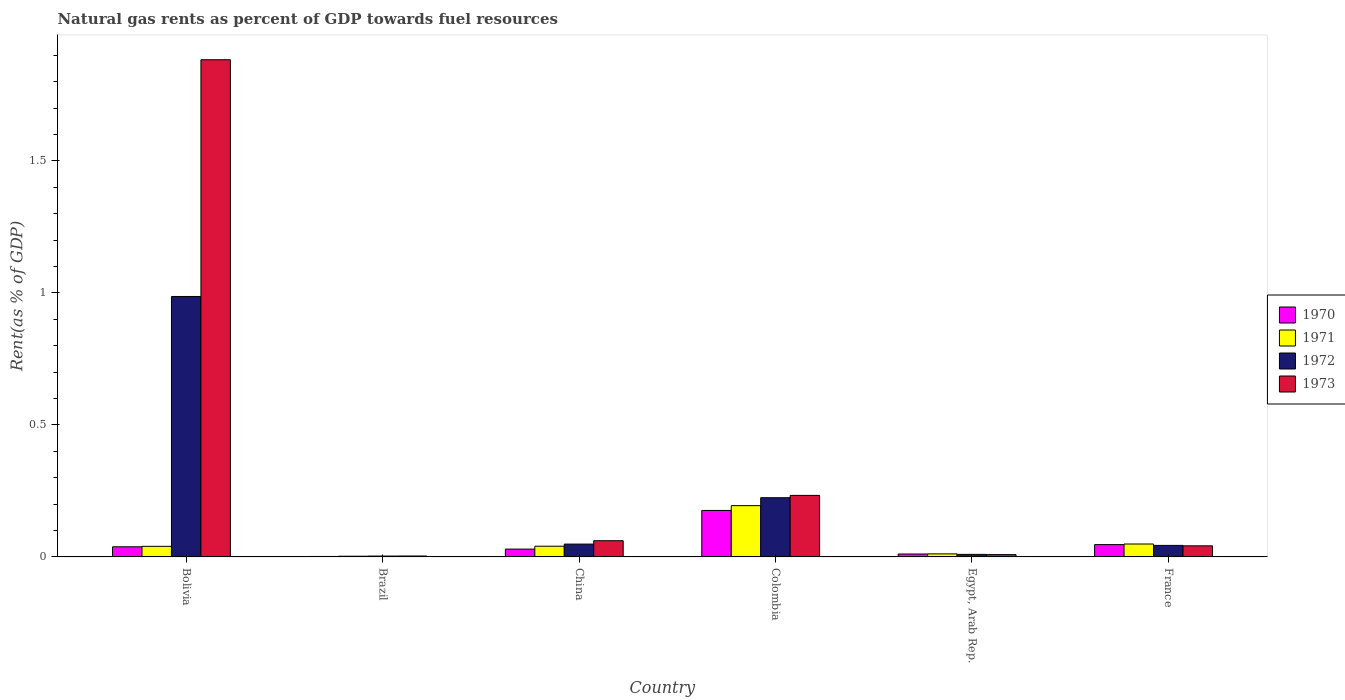How many different coloured bars are there?
Your answer should be compact. 4. Are the number of bars per tick equal to the number of legend labels?
Offer a very short reply. Yes. How many bars are there on the 6th tick from the right?
Make the answer very short. 4. What is the label of the 5th group of bars from the left?
Ensure brevity in your answer.  Egypt, Arab Rep. What is the matural gas rent in 1970 in Brazil?
Your response must be concise. 0. Across all countries, what is the maximum matural gas rent in 1971?
Provide a succinct answer. 0.19. Across all countries, what is the minimum matural gas rent in 1972?
Your answer should be very brief. 0. What is the total matural gas rent in 1971 in the graph?
Keep it short and to the point. 0.34. What is the difference between the matural gas rent in 1972 in Brazil and that in France?
Your response must be concise. -0.04. What is the difference between the matural gas rent in 1972 in China and the matural gas rent in 1971 in Egypt, Arab Rep.?
Offer a terse response. 0.04. What is the average matural gas rent in 1970 per country?
Give a very brief answer. 0.05. What is the difference between the matural gas rent of/in 1971 and matural gas rent of/in 1972 in Brazil?
Your response must be concise. -0. What is the ratio of the matural gas rent in 1971 in Colombia to that in France?
Keep it short and to the point. 3.97. What is the difference between the highest and the second highest matural gas rent in 1972?
Offer a terse response. 0.76. What is the difference between the highest and the lowest matural gas rent in 1970?
Provide a short and direct response. 0.17. Is the sum of the matural gas rent in 1971 in China and Colombia greater than the maximum matural gas rent in 1973 across all countries?
Your response must be concise. No. Is it the case that in every country, the sum of the matural gas rent in 1970 and matural gas rent in 1971 is greater than the sum of matural gas rent in 1973 and matural gas rent in 1972?
Provide a short and direct response. No. What does the 2nd bar from the left in China represents?
Make the answer very short. 1971. What does the 4th bar from the right in China represents?
Provide a succinct answer. 1970. Is it the case that in every country, the sum of the matural gas rent in 1972 and matural gas rent in 1973 is greater than the matural gas rent in 1971?
Provide a short and direct response. Yes. Does the graph contain grids?
Offer a very short reply. No. Where does the legend appear in the graph?
Offer a terse response. Center right. What is the title of the graph?
Make the answer very short. Natural gas rents as percent of GDP towards fuel resources. Does "1978" appear as one of the legend labels in the graph?
Offer a terse response. No. What is the label or title of the Y-axis?
Offer a terse response. Rent(as % of GDP). What is the Rent(as % of GDP) of 1970 in Bolivia?
Offer a very short reply. 0.04. What is the Rent(as % of GDP) of 1971 in Bolivia?
Keep it short and to the point. 0.04. What is the Rent(as % of GDP) in 1972 in Bolivia?
Provide a succinct answer. 0.99. What is the Rent(as % of GDP) in 1973 in Bolivia?
Keep it short and to the point. 1.88. What is the Rent(as % of GDP) in 1970 in Brazil?
Give a very brief answer. 0. What is the Rent(as % of GDP) in 1971 in Brazil?
Your answer should be compact. 0. What is the Rent(as % of GDP) in 1972 in Brazil?
Give a very brief answer. 0. What is the Rent(as % of GDP) in 1973 in Brazil?
Keep it short and to the point. 0. What is the Rent(as % of GDP) in 1970 in China?
Make the answer very short. 0.03. What is the Rent(as % of GDP) of 1971 in China?
Your answer should be compact. 0.04. What is the Rent(as % of GDP) of 1972 in China?
Provide a short and direct response. 0.05. What is the Rent(as % of GDP) in 1973 in China?
Ensure brevity in your answer.  0.06. What is the Rent(as % of GDP) in 1970 in Colombia?
Offer a terse response. 0.18. What is the Rent(as % of GDP) of 1971 in Colombia?
Your answer should be very brief. 0.19. What is the Rent(as % of GDP) of 1972 in Colombia?
Ensure brevity in your answer.  0.22. What is the Rent(as % of GDP) of 1973 in Colombia?
Provide a succinct answer. 0.23. What is the Rent(as % of GDP) of 1970 in Egypt, Arab Rep.?
Provide a succinct answer. 0.01. What is the Rent(as % of GDP) in 1971 in Egypt, Arab Rep.?
Offer a very short reply. 0.01. What is the Rent(as % of GDP) in 1972 in Egypt, Arab Rep.?
Provide a succinct answer. 0.01. What is the Rent(as % of GDP) of 1973 in Egypt, Arab Rep.?
Provide a succinct answer. 0.01. What is the Rent(as % of GDP) of 1970 in France?
Offer a very short reply. 0.05. What is the Rent(as % of GDP) of 1971 in France?
Offer a terse response. 0.05. What is the Rent(as % of GDP) in 1972 in France?
Provide a succinct answer. 0.04. What is the Rent(as % of GDP) of 1973 in France?
Give a very brief answer. 0.04. Across all countries, what is the maximum Rent(as % of GDP) of 1970?
Provide a short and direct response. 0.18. Across all countries, what is the maximum Rent(as % of GDP) in 1971?
Provide a short and direct response. 0.19. Across all countries, what is the maximum Rent(as % of GDP) of 1972?
Your response must be concise. 0.99. Across all countries, what is the maximum Rent(as % of GDP) in 1973?
Provide a succinct answer. 1.88. Across all countries, what is the minimum Rent(as % of GDP) of 1970?
Provide a short and direct response. 0. Across all countries, what is the minimum Rent(as % of GDP) of 1971?
Make the answer very short. 0. Across all countries, what is the minimum Rent(as % of GDP) in 1972?
Offer a very short reply. 0. Across all countries, what is the minimum Rent(as % of GDP) in 1973?
Offer a very short reply. 0. What is the total Rent(as % of GDP) in 1970 in the graph?
Provide a succinct answer. 0.3. What is the total Rent(as % of GDP) in 1971 in the graph?
Your answer should be compact. 0.34. What is the total Rent(as % of GDP) in 1972 in the graph?
Provide a succinct answer. 1.32. What is the total Rent(as % of GDP) in 1973 in the graph?
Your answer should be very brief. 2.23. What is the difference between the Rent(as % of GDP) in 1970 in Bolivia and that in Brazil?
Provide a short and direct response. 0.04. What is the difference between the Rent(as % of GDP) in 1971 in Bolivia and that in Brazil?
Make the answer very short. 0.04. What is the difference between the Rent(as % of GDP) of 1972 in Bolivia and that in Brazil?
Offer a very short reply. 0.98. What is the difference between the Rent(as % of GDP) of 1973 in Bolivia and that in Brazil?
Your answer should be compact. 1.88. What is the difference between the Rent(as % of GDP) of 1970 in Bolivia and that in China?
Give a very brief answer. 0.01. What is the difference between the Rent(as % of GDP) of 1971 in Bolivia and that in China?
Ensure brevity in your answer.  -0. What is the difference between the Rent(as % of GDP) in 1972 in Bolivia and that in China?
Offer a terse response. 0.94. What is the difference between the Rent(as % of GDP) of 1973 in Bolivia and that in China?
Your answer should be very brief. 1.82. What is the difference between the Rent(as % of GDP) in 1970 in Bolivia and that in Colombia?
Offer a terse response. -0.14. What is the difference between the Rent(as % of GDP) in 1971 in Bolivia and that in Colombia?
Your response must be concise. -0.15. What is the difference between the Rent(as % of GDP) of 1972 in Bolivia and that in Colombia?
Ensure brevity in your answer.  0.76. What is the difference between the Rent(as % of GDP) of 1973 in Bolivia and that in Colombia?
Make the answer very short. 1.65. What is the difference between the Rent(as % of GDP) in 1970 in Bolivia and that in Egypt, Arab Rep.?
Make the answer very short. 0.03. What is the difference between the Rent(as % of GDP) in 1971 in Bolivia and that in Egypt, Arab Rep.?
Make the answer very short. 0.03. What is the difference between the Rent(as % of GDP) in 1972 in Bolivia and that in Egypt, Arab Rep.?
Ensure brevity in your answer.  0.98. What is the difference between the Rent(as % of GDP) of 1973 in Bolivia and that in Egypt, Arab Rep.?
Provide a short and direct response. 1.87. What is the difference between the Rent(as % of GDP) in 1970 in Bolivia and that in France?
Ensure brevity in your answer.  -0.01. What is the difference between the Rent(as % of GDP) in 1971 in Bolivia and that in France?
Give a very brief answer. -0.01. What is the difference between the Rent(as % of GDP) of 1972 in Bolivia and that in France?
Provide a succinct answer. 0.94. What is the difference between the Rent(as % of GDP) in 1973 in Bolivia and that in France?
Your answer should be compact. 1.84. What is the difference between the Rent(as % of GDP) of 1970 in Brazil and that in China?
Your answer should be very brief. -0.03. What is the difference between the Rent(as % of GDP) of 1971 in Brazil and that in China?
Provide a succinct answer. -0.04. What is the difference between the Rent(as % of GDP) in 1972 in Brazil and that in China?
Offer a terse response. -0.05. What is the difference between the Rent(as % of GDP) in 1973 in Brazil and that in China?
Keep it short and to the point. -0.06. What is the difference between the Rent(as % of GDP) of 1970 in Brazil and that in Colombia?
Your response must be concise. -0.17. What is the difference between the Rent(as % of GDP) in 1971 in Brazil and that in Colombia?
Offer a very short reply. -0.19. What is the difference between the Rent(as % of GDP) in 1972 in Brazil and that in Colombia?
Provide a short and direct response. -0.22. What is the difference between the Rent(as % of GDP) in 1973 in Brazil and that in Colombia?
Your answer should be compact. -0.23. What is the difference between the Rent(as % of GDP) in 1970 in Brazil and that in Egypt, Arab Rep.?
Your answer should be very brief. -0.01. What is the difference between the Rent(as % of GDP) in 1971 in Brazil and that in Egypt, Arab Rep.?
Offer a terse response. -0.01. What is the difference between the Rent(as % of GDP) in 1972 in Brazil and that in Egypt, Arab Rep.?
Your response must be concise. -0.01. What is the difference between the Rent(as % of GDP) of 1973 in Brazil and that in Egypt, Arab Rep.?
Your answer should be very brief. -0.01. What is the difference between the Rent(as % of GDP) of 1970 in Brazil and that in France?
Give a very brief answer. -0.04. What is the difference between the Rent(as % of GDP) in 1971 in Brazil and that in France?
Your answer should be compact. -0.05. What is the difference between the Rent(as % of GDP) of 1972 in Brazil and that in France?
Offer a very short reply. -0.04. What is the difference between the Rent(as % of GDP) of 1973 in Brazil and that in France?
Offer a very short reply. -0.04. What is the difference between the Rent(as % of GDP) in 1970 in China and that in Colombia?
Make the answer very short. -0.15. What is the difference between the Rent(as % of GDP) of 1971 in China and that in Colombia?
Make the answer very short. -0.15. What is the difference between the Rent(as % of GDP) of 1972 in China and that in Colombia?
Provide a succinct answer. -0.18. What is the difference between the Rent(as % of GDP) of 1973 in China and that in Colombia?
Your answer should be compact. -0.17. What is the difference between the Rent(as % of GDP) in 1970 in China and that in Egypt, Arab Rep.?
Offer a terse response. 0.02. What is the difference between the Rent(as % of GDP) of 1971 in China and that in Egypt, Arab Rep.?
Give a very brief answer. 0.03. What is the difference between the Rent(as % of GDP) of 1972 in China and that in Egypt, Arab Rep.?
Provide a succinct answer. 0.04. What is the difference between the Rent(as % of GDP) in 1973 in China and that in Egypt, Arab Rep.?
Give a very brief answer. 0.05. What is the difference between the Rent(as % of GDP) of 1970 in China and that in France?
Give a very brief answer. -0.02. What is the difference between the Rent(as % of GDP) in 1971 in China and that in France?
Give a very brief answer. -0.01. What is the difference between the Rent(as % of GDP) of 1972 in China and that in France?
Your response must be concise. 0.01. What is the difference between the Rent(as % of GDP) in 1973 in China and that in France?
Your answer should be compact. 0.02. What is the difference between the Rent(as % of GDP) in 1970 in Colombia and that in Egypt, Arab Rep.?
Ensure brevity in your answer.  0.16. What is the difference between the Rent(as % of GDP) of 1971 in Colombia and that in Egypt, Arab Rep.?
Ensure brevity in your answer.  0.18. What is the difference between the Rent(as % of GDP) of 1972 in Colombia and that in Egypt, Arab Rep.?
Make the answer very short. 0.21. What is the difference between the Rent(as % of GDP) of 1973 in Colombia and that in Egypt, Arab Rep.?
Your answer should be very brief. 0.22. What is the difference between the Rent(as % of GDP) of 1970 in Colombia and that in France?
Provide a succinct answer. 0.13. What is the difference between the Rent(as % of GDP) of 1971 in Colombia and that in France?
Give a very brief answer. 0.15. What is the difference between the Rent(as % of GDP) in 1972 in Colombia and that in France?
Make the answer very short. 0.18. What is the difference between the Rent(as % of GDP) of 1973 in Colombia and that in France?
Offer a terse response. 0.19. What is the difference between the Rent(as % of GDP) in 1970 in Egypt, Arab Rep. and that in France?
Provide a short and direct response. -0.04. What is the difference between the Rent(as % of GDP) of 1971 in Egypt, Arab Rep. and that in France?
Your answer should be very brief. -0.04. What is the difference between the Rent(as % of GDP) in 1972 in Egypt, Arab Rep. and that in France?
Give a very brief answer. -0.03. What is the difference between the Rent(as % of GDP) in 1973 in Egypt, Arab Rep. and that in France?
Offer a terse response. -0.03. What is the difference between the Rent(as % of GDP) in 1970 in Bolivia and the Rent(as % of GDP) in 1971 in Brazil?
Your answer should be very brief. 0.04. What is the difference between the Rent(as % of GDP) of 1970 in Bolivia and the Rent(as % of GDP) of 1972 in Brazil?
Your answer should be very brief. 0.04. What is the difference between the Rent(as % of GDP) in 1970 in Bolivia and the Rent(as % of GDP) in 1973 in Brazil?
Give a very brief answer. 0.03. What is the difference between the Rent(as % of GDP) of 1971 in Bolivia and the Rent(as % of GDP) of 1972 in Brazil?
Your answer should be compact. 0.04. What is the difference between the Rent(as % of GDP) of 1971 in Bolivia and the Rent(as % of GDP) of 1973 in Brazil?
Keep it short and to the point. 0.04. What is the difference between the Rent(as % of GDP) in 1972 in Bolivia and the Rent(as % of GDP) in 1973 in Brazil?
Give a very brief answer. 0.98. What is the difference between the Rent(as % of GDP) in 1970 in Bolivia and the Rent(as % of GDP) in 1971 in China?
Your answer should be very brief. -0. What is the difference between the Rent(as % of GDP) of 1970 in Bolivia and the Rent(as % of GDP) of 1972 in China?
Provide a short and direct response. -0.01. What is the difference between the Rent(as % of GDP) of 1970 in Bolivia and the Rent(as % of GDP) of 1973 in China?
Your answer should be compact. -0.02. What is the difference between the Rent(as % of GDP) of 1971 in Bolivia and the Rent(as % of GDP) of 1972 in China?
Your answer should be very brief. -0.01. What is the difference between the Rent(as % of GDP) of 1971 in Bolivia and the Rent(as % of GDP) of 1973 in China?
Make the answer very short. -0.02. What is the difference between the Rent(as % of GDP) of 1972 in Bolivia and the Rent(as % of GDP) of 1973 in China?
Give a very brief answer. 0.92. What is the difference between the Rent(as % of GDP) in 1970 in Bolivia and the Rent(as % of GDP) in 1971 in Colombia?
Ensure brevity in your answer.  -0.16. What is the difference between the Rent(as % of GDP) of 1970 in Bolivia and the Rent(as % of GDP) of 1972 in Colombia?
Offer a very short reply. -0.19. What is the difference between the Rent(as % of GDP) of 1970 in Bolivia and the Rent(as % of GDP) of 1973 in Colombia?
Offer a very short reply. -0.19. What is the difference between the Rent(as % of GDP) of 1971 in Bolivia and the Rent(as % of GDP) of 1972 in Colombia?
Your answer should be compact. -0.18. What is the difference between the Rent(as % of GDP) of 1971 in Bolivia and the Rent(as % of GDP) of 1973 in Colombia?
Keep it short and to the point. -0.19. What is the difference between the Rent(as % of GDP) in 1972 in Bolivia and the Rent(as % of GDP) in 1973 in Colombia?
Provide a succinct answer. 0.75. What is the difference between the Rent(as % of GDP) of 1970 in Bolivia and the Rent(as % of GDP) of 1971 in Egypt, Arab Rep.?
Your response must be concise. 0.03. What is the difference between the Rent(as % of GDP) of 1970 in Bolivia and the Rent(as % of GDP) of 1972 in Egypt, Arab Rep.?
Provide a short and direct response. 0.03. What is the difference between the Rent(as % of GDP) of 1970 in Bolivia and the Rent(as % of GDP) of 1973 in Egypt, Arab Rep.?
Provide a short and direct response. 0.03. What is the difference between the Rent(as % of GDP) of 1971 in Bolivia and the Rent(as % of GDP) of 1972 in Egypt, Arab Rep.?
Your answer should be compact. 0.03. What is the difference between the Rent(as % of GDP) of 1971 in Bolivia and the Rent(as % of GDP) of 1973 in Egypt, Arab Rep.?
Your answer should be very brief. 0.03. What is the difference between the Rent(as % of GDP) of 1972 in Bolivia and the Rent(as % of GDP) of 1973 in Egypt, Arab Rep.?
Your answer should be compact. 0.98. What is the difference between the Rent(as % of GDP) of 1970 in Bolivia and the Rent(as % of GDP) of 1971 in France?
Offer a terse response. -0.01. What is the difference between the Rent(as % of GDP) of 1970 in Bolivia and the Rent(as % of GDP) of 1972 in France?
Give a very brief answer. -0.01. What is the difference between the Rent(as % of GDP) in 1970 in Bolivia and the Rent(as % of GDP) in 1973 in France?
Provide a succinct answer. -0. What is the difference between the Rent(as % of GDP) of 1971 in Bolivia and the Rent(as % of GDP) of 1972 in France?
Your response must be concise. -0. What is the difference between the Rent(as % of GDP) of 1971 in Bolivia and the Rent(as % of GDP) of 1973 in France?
Provide a succinct answer. -0. What is the difference between the Rent(as % of GDP) in 1972 in Bolivia and the Rent(as % of GDP) in 1973 in France?
Keep it short and to the point. 0.94. What is the difference between the Rent(as % of GDP) of 1970 in Brazil and the Rent(as % of GDP) of 1971 in China?
Offer a terse response. -0.04. What is the difference between the Rent(as % of GDP) of 1970 in Brazil and the Rent(as % of GDP) of 1972 in China?
Offer a terse response. -0.05. What is the difference between the Rent(as % of GDP) of 1970 in Brazil and the Rent(as % of GDP) of 1973 in China?
Your answer should be very brief. -0.06. What is the difference between the Rent(as % of GDP) in 1971 in Brazil and the Rent(as % of GDP) in 1972 in China?
Provide a succinct answer. -0.05. What is the difference between the Rent(as % of GDP) of 1971 in Brazil and the Rent(as % of GDP) of 1973 in China?
Your answer should be compact. -0.06. What is the difference between the Rent(as % of GDP) of 1972 in Brazil and the Rent(as % of GDP) of 1973 in China?
Make the answer very short. -0.06. What is the difference between the Rent(as % of GDP) of 1970 in Brazil and the Rent(as % of GDP) of 1971 in Colombia?
Give a very brief answer. -0.19. What is the difference between the Rent(as % of GDP) in 1970 in Brazil and the Rent(as % of GDP) in 1972 in Colombia?
Give a very brief answer. -0.22. What is the difference between the Rent(as % of GDP) of 1970 in Brazil and the Rent(as % of GDP) of 1973 in Colombia?
Provide a short and direct response. -0.23. What is the difference between the Rent(as % of GDP) of 1971 in Brazil and the Rent(as % of GDP) of 1972 in Colombia?
Offer a terse response. -0.22. What is the difference between the Rent(as % of GDP) of 1971 in Brazil and the Rent(as % of GDP) of 1973 in Colombia?
Offer a terse response. -0.23. What is the difference between the Rent(as % of GDP) of 1972 in Brazil and the Rent(as % of GDP) of 1973 in Colombia?
Provide a short and direct response. -0.23. What is the difference between the Rent(as % of GDP) of 1970 in Brazil and the Rent(as % of GDP) of 1971 in Egypt, Arab Rep.?
Ensure brevity in your answer.  -0.01. What is the difference between the Rent(as % of GDP) in 1970 in Brazil and the Rent(as % of GDP) in 1972 in Egypt, Arab Rep.?
Make the answer very short. -0.01. What is the difference between the Rent(as % of GDP) of 1970 in Brazil and the Rent(as % of GDP) of 1973 in Egypt, Arab Rep.?
Keep it short and to the point. -0.01. What is the difference between the Rent(as % of GDP) in 1971 in Brazil and the Rent(as % of GDP) in 1972 in Egypt, Arab Rep.?
Provide a succinct answer. -0.01. What is the difference between the Rent(as % of GDP) of 1971 in Brazil and the Rent(as % of GDP) of 1973 in Egypt, Arab Rep.?
Provide a succinct answer. -0.01. What is the difference between the Rent(as % of GDP) of 1972 in Brazil and the Rent(as % of GDP) of 1973 in Egypt, Arab Rep.?
Give a very brief answer. -0.01. What is the difference between the Rent(as % of GDP) in 1970 in Brazil and the Rent(as % of GDP) in 1971 in France?
Ensure brevity in your answer.  -0.05. What is the difference between the Rent(as % of GDP) of 1970 in Brazil and the Rent(as % of GDP) of 1972 in France?
Keep it short and to the point. -0.04. What is the difference between the Rent(as % of GDP) in 1970 in Brazil and the Rent(as % of GDP) in 1973 in France?
Offer a very short reply. -0.04. What is the difference between the Rent(as % of GDP) in 1971 in Brazil and the Rent(as % of GDP) in 1972 in France?
Offer a terse response. -0.04. What is the difference between the Rent(as % of GDP) of 1971 in Brazil and the Rent(as % of GDP) of 1973 in France?
Provide a short and direct response. -0.04. What is the difference between the Rent(as % of GDP) of 1972 in Brazil and the Rent(as % of GDP) of 1973 in France?
Your answer should be compact. -0.04. What is the difference between the Rent(as % of GDP) in 1970 in China and the Rent(as % of GDP) in 1971 in Colombia?
Ensure brevity in your answer.  -0.16. What is the difference between the Rent(as % of GDP) of 1970 in China and the Rent(as % of GDP) of 1972 in Colombia?
Give a very brief answer. -0.19. What is the difference between the Rent(as % of GDP) in 1970 in China and the Rent(as % of GDP) in 1973 in Colombia?
Your response must be concise. -0.2. What is the difference between the Rent(as % of GDP) of 1971 in China and the Rent(as % of GDP) of 1972 in Colombia?
Make the answer very short. -0.18. What is the difference between the Rent(as % of GDP) in 1971 in China and the Rent(as % of GDP) in 1973 in Colombia?
Make the answer very short. -0.19. What is the difference between the Rent(as % of GDP) in 1972 in China and the Rent(as % of GDP) in 1973 in Colombia?
Provide a short and direct response. -0.18. What is the difference between the Rent(as % of GDP) in 1970 in China and the Rent(as % of GDP) in 1971 in Egypt, Arab Rep.?
Offer a terse response. 0.02. What is the difference between the Rent(as % of GDP) in 1970 in China and the Rent(as % of GDP) in 1972 in Egypt, Arab Rep.?
Provide a short and direct response. 0.02. What is the difference between the Rent(as % of GDP) in 1970 in China and the Rent(as % of GDP) in 1973 in Egypt, Arab Rep.?
Your answer should be very brief. 0.02. What is the difference between the Rent(as % of GDP) in 1971 in China and the Rent(as % of GDP) in 1972 in Egypt, Arab Rep.?
Give a very brief answer. 0.03. What is the difference between the Rent(as % of GDP) of 1971 in China and the Rent(as % of GDP) of 1973 in Egypt, Arab Rep.?
Make the answer very short. 0.03. What is the difference between the Rent(as % of GDP) of 1972 in China and the Rent(as % of GDP) of 1973 in Egypt, Arab Rep.?
Your answer should be very brief. 0.04. What is the difference between the Rent(as % of GDP) in 1970 in China and the Rent(as % of GDP) in 1971 in France?
Provide a short and direct response. -0.02. What is the difference between the Rent(as % of GDP) in 1970 in China and the Rent(as % of GDP) in 1972 in France?
Your answer should be very brief. -0.01. What is the difference between the Rent(as % of GDP) in 1970 in China and the Rent(as % of GDP) in 1973 in France?
Give a very brief answer. -0.01. What is the difference between the Rent(as % of GDP) of 1971 in China and the Rent(as % of GDP) of 1972 in France?
Ensure brevity in your answer.  -0. What is the difference between the Rent(as % of GDP) in 1971 in China and the Rent(as % of GDP) in 1973 in France?
Offer a terse response. -0. What is the difference between the Rent(as % of GDP) in 1972 in China and the Rent(as % of GDP) in 1973 in France?
Your answer should be compact. 0.01. What is the difference between the Rent(as % of GDP) in 1970 in Colombia and the Rent(as % of GDP) in 1971 in Egypt, Arab Rep.?
Ensure brevity in your answer.  0.16. What is the difference between the Rent(as % of GDP) in 1970 in Colombia and the Rent(as % of GDP) in 1972 in Egypt, Arab Rep.?
Give a very brief answer. 0.17. What is the difference between the Rent(as % of GDP) of 1970 in Colombia and the Rent(as % of GDP) of 1973 in Egypt, Arab Rep.?
Your answer should be very brief. 0.17. What is the difference between the Rent(as % of GDP) in 1971 in Colombia and the Rent(as % of GDP) in 1972 in Egypt, Arab Rep.?
Make the answer very short. 0.18. What is the difference between the Rent(as % of GDP) in 1971 in Colombia and the Rent(as % of GDP) in 1973 in Egypt, Arab Rep.?
Your answer should be compact. 0.19. What is the difference between the Rent(as % of GDP) in 1972 in Colombia and the Rent(as % of GDP) in 1973 in Egypt, Arab Rep.?
Your answer should be compact. 0.22. What is the difference between the Rent(as % of GDP) of 1970 in Colombia and the Rent(as % of GDP) of 1971 in France?
Keep it short and to the point. 0.13. What is the difference between the Rent(as % of GDP) in 1970 in Colombia and the Rent(as % of GDP) in 1972 in France?
Provide a short and direct response. 0.13. What is the difference between the Rent(as % of GDP) in 1970 in Colombia and the Rent(as % of GDP) in 1973 in France?
Make the answer very short. 0.13. What is the difference between the Rent(as % of GDP) of 1971 in Colombia and the Rent(as % of GDP) of 1972 in France?
Offer a very short reply. 0.15. What is the difference between the Rent(as % of GDP) of 1971 in Colombia and the Rent(as % of GDP) of 1973 in France?
Make the answer very short. 0.15. What is the difference between the Rent(as % of GDP) in 1972 in Colombia and the Rent(as % of GDP) in 1973 in France?
Offer a terse response. 0.18. What is the difference between the Rent(as % of GDP) in 1970 in Egypt, Arab Rep. and the Rent(as % of GDP) in 1971 in France?
Provide a short and direct response. -0.04. What is the difference between the Rent(as % of GDP) of 1970 in Egypt, Arab Rep. and the Rent(as % of GDP) of 1972 in France?
Ensure brevity in your answer.  -0.03. What is the difference between the Rent(as % of GDP) of 1970 in Egypt, Arab Rep. and the Rent(as % of GDP) of 1973 in France?
Ensure brevity in your answer.  -0.03. What is the difference between the Rent(as % of GDP) of 1971 in Egypt, Arab Rep. and the Rent(as % of GDP) of 1972 in France?
Provide a short and direct response. -0.03. What is the difference between the Rent(as % of GDP) in 1971 in Egypt, Arab Rep. and the Rent(as % of GDP) in 1973 in France?
Give a very brief answer. -0.03. What is the difference between the Rent(as % of GDP) of 1972 in Egypt, Arab Rep. and the Rent(as % of GDP) of 1973 in France?
Keep it short and to the point. -0.03. What is the average Rent(as % of GDP) of 1970 per country?
Make the answer very short. 0.05. What is the average Rent(as % of GDP) of 1971 per country?
Offer a terse response. 0.06. What is the average Rent(as % of GDP) of 1972 per country?
Keep it short and to the point. 0.22. What is the average Rent(as % of GDP) in 1973 per country?
Give a very brief answer. 0.37. What is the difference between the Rent(as % of GDP) of 1970 and Rent(as % of GDP) of 1971 in Bolivia?
Your answer should be compact. -0. What is the difference between the Rent(as % of GDP) in 1970 and Rent(as % of GDP) in 1972 in Bolivia?
Offer a very short reply. -0.95. What is the difference between the Rent(as % of GDP) in 1970 and Rent(as % of GDP) in 1973 in Bolivia?
Give a very brief answer. -1.84. What is the difference between the Rent(as % of GDP) in 1971 and Rent(as % of GDP) in 1972 in Bolivia?
Give a very brief answer. -0.95. What is the difference between the Rent(as % of GDP) in 1971 and Rent(as % of GDP) in 1973 in Bolivia?
Ensure brevity in your answer.  -1.84. What is the difference between the Rent(as % of GDP) of 1972 and Rent(as % of GDP) of 1973 in Bolivia?
Offer a terse response. -0.9. What is the difference between the Rent(as % of GDP) in 1970 and Rent(as % of GDP) in 1971 in Brazil?
Give a very brief answer. -0. What is the difference between the Rent(as % of GDP) in 1970 and Rent(as % of GDP) in 1972 in Brazil?
Provide a short and direct response. -0. What is the difference between the Rent(as % of GDP) in 1970 and Rent(as % of GDP) in 1973 in Brazil?
Ensure brevity in your answer.  -0. What is the difference between the Rent(as % of GDP) of 1971 and Rent(as % of GDP) of 1972 in Brazil?
Ensure brevity in your answer.  -0. What is the difference between the Rent(as % of GDP) of 1971 and Rent(as % of GDP) of 1973 in Brazil?
Provide a succinct answer. -0. What is the difference between the Rent(as % of GDP) in 1972 and Rent(as % of GDP) in 1973 in Brazil?
Provide a short and direct response. -0. What is the difference between the Rent(as % of GDP) in 1970 and Rent(as % of GDP) in 1971 in China?
Offer a very short reply. -0.01. What is the difference between the Rent(as % of GDP) in 1970 and Rent(as % of GDP) in 1972 in China?
Provide a succinct answer. -0.02. What is the difference between the Rent(as % of GDP) in 1970 and Rent(as % of GDP) in 1973 in China?
Ensure brevity in your answer.  -0.03. What is the difference between the Rent(as % of GDP) of 1971 and Rent(as % of GDP) of 1972 in China?
Give a very brief answer. -0.01. What is the difference between the Rent(as % of GDP) of 1971 and Rent(as % of GDP) of 1973 in China?
Provide a succinct answer. -0.02. What is the difference between the Rent(as % of GDP) in 1972 and Rent(as % of GDP) in 1973 in China?
Your answer should be very brief. -0.01. What is the difference between the Rent(as % of GDP) of 1970 and Rent(as % of GDP) of 1971 in Colombia?
Ensure brevity in your answer.  -0.02. What is the difference between the Rent(as % of GDP) of 1970 and Rent(as % of GDP) of 1972 in Colombia?
Ensure brevity in your answer.  -0.05. What is the difference between the Rent(as % of GDP) in 1970 and Rent(as % of GDP) in 1973 in Colombia?
Your response must be concise. -0.06. What is the difference between the Rent(as % of GDP) of 1971 and Rent(as % of GDP) of 1972 in Colombia?
Offer a very short reply. -0.03. What is the difference between the Rent(as % of GDP) of 1971 and Rent(as % of GDP) of 1973 in Colombia?
Give a very brief answer. -0.04. What is the difference between the Rent(as % of GDP) in 1972 and Rent(as % of GDP) in 1973 in Colombia?
Offer a terse response. -0.01. What is the difference between the Rent(as % of GDP) in 1970 and Rent(as % of GDP) in 1971 in Egypt, Arab Rep.?
Provide a short and direct response. -0. What is the difference between the Rent(as % of GDP) in 1970 and Rent(as % of GDP) in 1972 in Egypt, Arab Rep.?
Offer a terse response. 0. What is the difference between the Rent(as % of GDP) in 1970 and Rent(as % of GDP) in 1973 in Egypt, Arab Rep.?
Provide a short and direct response. 0. What is the difference between the Rent(as % of GDP) of 1971 and Rent(as % of GDP) of 1972 in Egypt, Arab Rep.?
Provide a succinct answer. 0. What is the difference between the Rent(as % of GDP) in 1971 and Rent(as % of GDP) in 1973 in Egypt, Arab Rep.?
Give a very brief answer. 0. What is the difference between the Rent(as % of GDP) in 1972 and Rent(as % of GDP) in 1973 in Egypt, Arab Rep.?
Provide a short and direct response. 0. What is the difference between the Rent(as % of GDP) in 1970 and Rent(as % of GDP) in 1971 in France?
Provide a succinct answer. -0. What is the difference between the Rent(as % of GDP) in 1970 and Rent(as % of GDP) in 1972 in France?
Offer a terse response. 0. What is the difference between the Rent(as % of GDP) of 1970 and Rent(as % of GDP) of 1973 in France?
Your answer should be compact. 0. What is the difference between the Rent(as % of GDP) of 1971 and Rent(as % of GDP) of 1972 in France?
Your answer should be very brief. 0.01. What is the difference between the Rent(as % of GDP) of 1971 and Rent(as % of GDP) of 1973 in France?
Offer a very short reply. 0.01. What is the difference between the Rent(as % of GDP) in 1972 and Rent(as % of GDP) in 1973 in France?
Offer a very short reply. 0. What is the ratio of the Rent(as % of GDP) of 1970 in Bolivia to that in Brazil?
Give a very brief answer. 21.58. What is the ratio of the Rent(as % of GDP) of 1971 in Bolivia to that in Brazil?
Your answer should be very brief. 14.62. What is the ratio of the Rent(as % of GDP) in 1972 in Bolivia to that in Brazil?
Keep it short and to the point. 297.41. What is the ratio of the Rent(as % of GDP) of 1973 in Bolivia to that in Brazil?
Ensure brevity in your answer.  539.46. What is the ratio of the Rent(as % of GDP) of 1970 in Bolivia to that in China?
Ensure brevity in your answer.  1.3. What is the ratio of the Rent(as % of GDP) in 1971 in Bolivia to that in China?
Ensure brevity in your answer.  0.99. What is the ratio of the Rent(as % of GDP) of 1972 in Bolivia to that in China?
Your response must be concise. 20.28. What is the ratio of the Rent(as % of GDP) of 1973 in Bolivia to that in China?
Your answer should be very brief. 30.65. What is the ratio of the Rent(as % of GDP) of 1970 in Bolivia to that in Colombia?
Offer a terse response. 0.22. What is the ratio of the Rent(as % of GDP) in 1971 in Bolivia to that in Colombia?
Provide a succinct answer. 0.21. What is the ratio of the Rent(as % of GDP) in 1972 in Bolivia to that in Colombia?
Offer a very short reply. 4.4. What is the ratio of the Rent(as % of GDP) of 1973 in Bolivia to that in Colombia?
Offer a very short reply. 8.08. What is the ratio of the Rent(as % of GDP) in 1970 in Bolivia to that in Egypt, Arab Rep.?
Provide a succinct answer. 3.47. What is the ratio of the Rent(as % of GDP) in 1971 in Bolivia to that in Egypt, Arab Rep.?
Your answer should be compact. 3.48. What is the ratio of the Rent(as % of GDP) in 1972 in Bolivia to that in Egypt, Arab Rep.?
Offer a very short reply. 102.27. What is the ratio of the Rent(as % of GDP) in 1973 in Bolivia to that in Egypt, Arab Rep.?
Provide a succinct answer. 214.93. What is the ratio of the Rent(as % of GDP) in 1970 in Bolivia to that in France?
Offer a terse response. 0.82. What is the ratio of the Rent(as % of GDP) in 1971 in Bolivia to that in France?
Your answer should be very brief. 0.82. What is the ratio of the Rent(as % of GDP) of 1972 in Bolivia to that in France?
Make the answer very short. 22.6. What is the ratio of the Rent(as % of GDP) in 1973 in Bolivia to that in France?
Offer a terse response. 44.81. What is the ratio of the Rent(as % of GDP) in 1971 in Brazil to that in China?
Provide a succinct answer. 0.07. What is the ratio of the Rent(as % of GDP) in 1972 in Brazil to that in China?
Keep it short and to the point. 0.07. What is the ratio of the Rent(as % of GDP) of 1973 in Brazil to that in China?
Ensure brevity in your answer.  0.06. What is the ratio of the Rent(as % of GDP) in 1970 in Brazil to that in Colombia?
Keep it short and to the point. 0.01. What is the ratio of the Rent(as % of GDP) of 1971 in Brazil to that in Colombia?
Keep it short and to the point. 0.01. What is the ratio of the Rent(as % of GDP) in 1972 in Brazil to that in Colombia?
Your answer should be very brief. 0.01. What is the ratio of the Rent(as % of GDP) of 1973 in Brazil to that in Colombia?
Make the answer very short. 0.01. What is the ratio of the Rent(as % of GDP) of 1970 in Brazil to that in Egypt, Arab Rep.?
Your response must be concise. 0.16. What is the ratio of the Rent(as % of GDP) in 1971 in Brazil to that in Egypt, Arab Rep.?
Ensure brevity in your answer.  0.24. What is the ratio of the Rent(as % of GDP) in 1972 in Brazil to that in Egypt, Arab Rep.?
Make the answer very short. 0.34. What is the ratio of the Rent(as % of GDP) of 1973 in Brazil to that in Egypt, Arab Rep.?
Your answer should be very brief. 0.4. What is the ratio of the Rent(as % of GDP) of 1970 in Brazil to that in France?
Offer a very short reply. 0.04. What is the ratio of the Rent(as % of GDP) in 1971 in Brazil to that in France?
Provide a short and direct response. 0.06. What is the ratio of the Rent(as % of GDP) of 1972 in Brazil to that in France?
Give a very brief answer. 0.08. What is the ratio of the Rent(as % of GDP) in 1973 in Brazil to that in France?
Give a very brief answer. 0.08. What is the ratio of the Rent(as % of GDP) of 1970 in China to that in Colombia?
Give a very brief answer. 0.17. What is the ratio of the Rent(as % of GDP) in 1971 in China to that in Colombia?
Keep it short and to the point. 0.21. What is the ratio of the Rent(as % of GDP) of 1972 in China to that in Colombia?
Give a very brief answer. 0.22. What is the ratio of the Rent(as % of GDP) in 1973 in China to that in Colombia?
Make the answer very short. 0.26. What is the ratio of the Rent(as % of GDP) of 1970 in China to that in Egypt, Arab Rep.?
Your answer should be compact. 2.68. What is the ratio of the Rent(as % of GDP) in 1971 in China to that in Egypt, Arab Rep.?
Keep it short and to the point. 3.52. What is the ratio of the Rent(as % of GDP) of 1972 in China to that in Egypt, Arab Rep.?
Offer a terse response. 5.04. What is the ratio of the Rent(as % of GDP) in 1973 in China to that in Egypt, Arab Rep.?
Make the answer very short. 7.01. What is the ratio of the Rent(as % of GDP) in 1970 in China to that in France?
Give a very brief answer. 0.64. What is the ratio of the Rent(as % of GDP) in 1971 in China to that in France?
Ensure brevity in your answer.  0.83. What is the ratio of the Rent(as % of GDP) in 1972 in China to that in France?
Offer a terse response. 1.11. What is the ratio of the Rent(as % of GDP) in 1973 in China to that in France?
Offer a very short reply. 1.46. What is the ratio of the Rent(as % of GDP) of 1970 in Colombia to that in Egypt, Arab Rep.?
Provide a short and direct response. 15.9. What is the ratio of the Rent(as % of GDP) of 1971 in Colombia to that in Egypt, Arab Rep.?
Your answer should be compact. 16.84. What is the ratio of the Rent(as % of GDP) of 1972 in Colombia to that in Egypt, Arab Rep.?
Offer a terse response. 23.25. What is the ratio of the Rent(as % of GDP) of 1973 in Colombia to that in Egypt, Arab Rep.?
Offer a very short reply. 26.6. What is the ratio of the Rent(as % of GDP) in 1970 in Colombia to that in France?
Provide a short and direct response. 3.77. What is the ratio of the Rent(as % of GDP) in 1971 in Colombia to that in France?
Offer a very short reply. 3.97. What is the ratio of the Rent(as % of GDP) of 1972 in Colombia to that in France?
Your answer should be compact. 5.14. What is the ratio of the Rent(as % of GDP) of 1973 in Colombia to that in France?
Your response must be concise. 5.55. What is the ratio of the Rent(as % of GDP) in 1970 in Egypt, Arab Rep. to that in France?
Ensure brevity in your answer.  0.24. What is the ratio of the Rent(as % of GDP) in 1971 in Egypt, Arab Rep. to that in France?
Offer a terse response. 0.24. What is the ratio of the Rent(as % of GDP) of 1972 in Egypt, Arab Rep. to that in France?
Your answer should be very brief. 0.22. What is the ratio of the Rent(as % of GDP) in 1973 in Egypt, Arab Rep. to that in France?
Ensure brevity in your answer.  0.21. What is the difference between the highest and the second highest Rent(as % of GDP) in 1970?
Your answer should be very brief. 0.13. What is the difference between the highest and the second highest Rent(as % of GDP) in 1971?
Your response must be concise. 0.15. What is the difference between the highest and the second highest Rent(as % of GDP) of 1972?
Make the answer very short. 0.76. What is the difference between the highest and the second highest Rent(as % of GDP) in 1973?
Make the answer very short. 1.65. What is the difference between the highest and the lowest Rent(as % of GDP) in 1970?
Offer a very short reply. 0.17. What is the difference between the highest and the lowest Rent(as % of GDP) in 1971?
Your response must be concise. 0.19. What is the difference between the highest and the lowest Rent(as % of GDP) of 1972?
Ensure brevity in your answer.  0.98. What is the difference between the highest and the lowest Rent(as % of GDP) of 1973?
Offer a terse response. 1.88. 